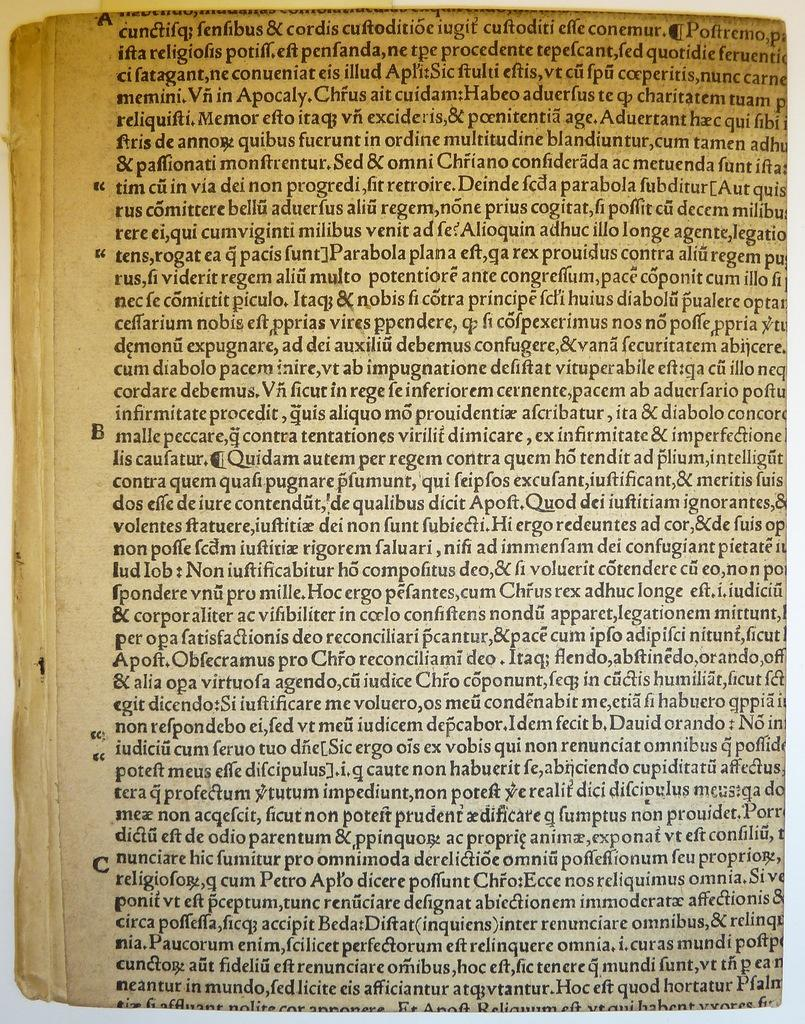What is the main subject of the image? The main subject of the image is a page of a book. What can be found on the page? There is text on the page. What type of meal is being prepared on the page of the book? There is no meal being prepared on the page of the book; it only contains text. Can you hear a cow crying in the image? There is no cow or any sound in the image, as it is a static representation of a page of a book. 